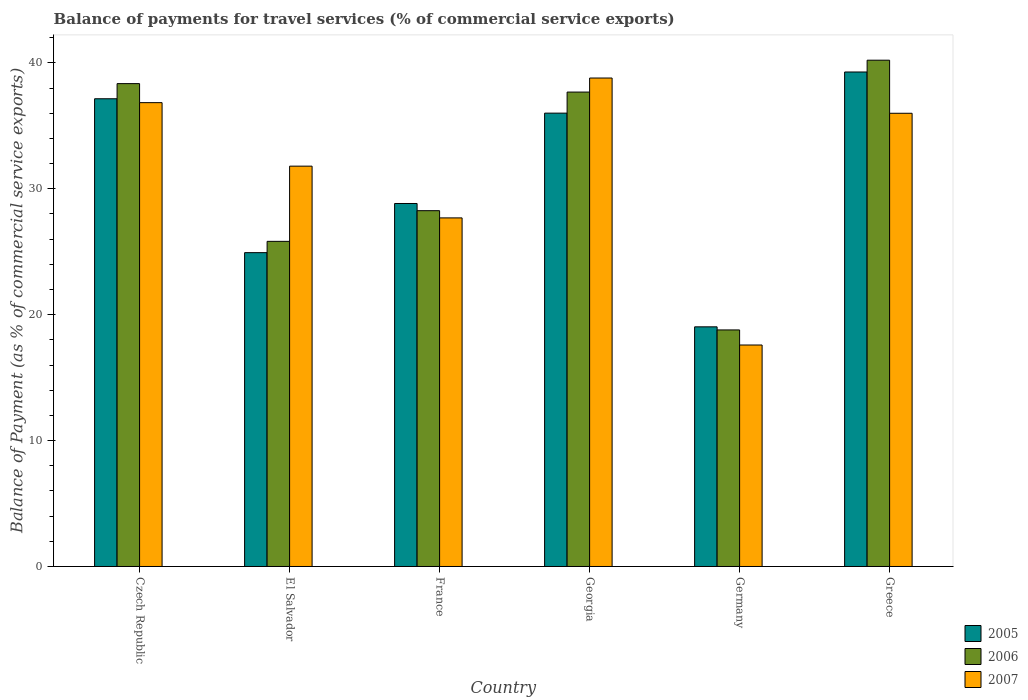How many different coloured bars are there?
Provide a succinct answer. 3. How many groups of bars are there?
Keep it short and to the point. 6. Are the number of bars per tick equal to the number of legend labels?
Keep it short and to the point. Yes. In how many cases, is the number of bars for a given country not equal to the number of legend labels?
Your answer should be compact. 0. What is the balance of payments for travel services in 2007 in El Salvador?
Your answer should be compact. 31.8. Across all countries, what is the maximum balance of payments for travel services in 2006?
Give a very brief answer. 40.22. Across all countries, what is the minimum balance of payments for travel services in 2005?
Make the answer very short. 19.04. In which country was the balance of payments for travel services in 2005 maximum?
Keep it short and to the point. Greece. In which country was the balance of payments for travel services in 2005 minimum?
Give a very brief answer. Germany. What is the total balance of payments for travel services in 2005 in the graph?
Offer a very short reply. 185.24. What is the difference between the balance of payments for travel services in 2005 in Czech Republic and that in Greece?
Ensure brevity in your answer.  -2.13. What is the difference between the balance of payments for travel services in 2006 in Germany and the balance of payments for travel services in 2005 in Georgia?
Ensure brevity in your answer.  -17.22. What is the average balance of payments for travel services in 2006 per country?
Provide a short and direct response. 31.52. What is the difference between the balance of payments for travel services of/in 2005 and balance of payments for travel services of/in 2007 in El Salvador?
Provide a short and direct response. -6.87. In how many countries, is the balance of payments for travel services in 2007 greater than 8 %?
Ensure brevity in your answer.  6. What is the ratio of the balance of payments for travel services in 2006 in Czech Republic to that in Greece?
Give a very brief answer. 0.95. Is the balance of payments for travel services in 2007 in Czech Republic less than that in Germany?
Give a very brief answer. No. What is the difference between the highest and the second highest balance of payments for travel services in 2007?
Keep it short and to the point. -0.84. What is the difference between the highest and the lowest balance of payments for travel services in 2007?
Your answer should be very brief. 21.21. What does the 2nd bar from the left in Czech Republic represents?
Keep it short and to the point. 2006. What does the 1st bar from the right in Greece represents?
Keep it short and to the point. 2007. Is it the case that in every country, the sum of the balance of payments for travel services in 2006 and balance of payments for travel services in 2005 is greater than the balance of payments for travel services in 2007?
Keep it short and to the point. Yes. How many countries are there in the graph?
Provide a succinct answer. 6. What is the difference between two consecutive major ticks on the Y-axis?
Your answer should be compact. 10. Are the values on the major ticks of Y-axis written in scientific E-notation?
Provide a succinct answer. No. Does the graph contain any zero values?
Offer a very short reply. No. Where does the legend appear in the graph?
Provide a short and direct response. Bottom right. How many legend labels are there?
Offer a terse response. 3. What is the title of the graph?
Your response must be concise. Balance of payments for travel services (% of commercial service exports). What is the label or title of the Y-axis?
Provide a succinct answer. Balance of Payment (as % of commercial service exports). What is the Balance of Payment (as % of commercial service exports) in 2005 in Czech Republic?
Your answer should be compact. 37.15. What is the Balance of Payment (as % of commercial service exports) of 2006 in Czech Republic?
Make the answer very short. 38.36. What is the Balance of Payment (as % of commercial service exports) in 2007 in Czech Republic?
Make the answer very short. 36.84. What is the Balance of Payment (as % of commercial service exports) in 2005 in El Salvador?
Your answer should be very brief. 24.93. What is the Balance of Payment (as % of commercial service exports) in 2006 in El Salvador?
Offer a terse response. 25.83. What is the Balance of Payment (as % of commercial service exports) in 2007 in El Salvador?
Your response must be concise. 31.8. What is the Balance of Payment (as % of commercial service exports) of 2005 in France?
Offer a terse response. 28.83. What is the Balance of Payment (as % of commercial service exports) in 2006 in France?
Provide a succinct answer. 28.26. What is the Balance of Payment (as % of commercial service exports) of 2007 in France?
Your response must be concise. 27.69. What is the Balance of Payment (as % of commercial service exports) in 2005 in Georgia?
Offer a terse response. 36.01. What is the Balance of Payment (as % of commercial service exports) of 2006 in Georgia?
Keep it short and to the point. 37.68. What is the Balance of Payment (as % of commercial service exports) in 2007 in Georgia?
Ensure brevity in your answer.  38.8. What is the Balance of Payment (as % of commercial service exports) in 2005 in Germany?
Your answer should be compact. 19.04. What is the Balance of Payment (as % of commercial service exports) in 2006 in Germany?
Your response must be concise. 18.79. What is the Balance of Payment (as % of commercial service exports) in 2007 in Germany?
Keep it short and to the point. 17.59. What is the Balance of Payment (as % of commercial service exports) in 2005 in Greece?
Your answer should be very brief. 39.28. What is the Balance of Payment (as % of commercial service exports) of 2006 in Greece?
Keep it short and to the point. 40.22. What is the Balance of Payment (as % of commercial service exports) in 2007 in Greece?
Your answer should be compact. 36. Across all countries, what is the maximum Balance of Payment (as % of commercial service exports) in 2005?
Provide a short and direct response. 39.28. Across all countries, what is the maximum Balance of Payment (as % of commercial service exports) of 2006?
Give a very brief answer. 40.22. Across all countries, what is the maximum Balance of Payment (as % of commercial service exports) in 2007?
Your answer should be very brief. 38.8. Across all countries, what is the minimum Balance of Payment (as % of commercial service exports) in 2005?
Give a very brief answer. 19.04. Across all countries, what is the minimum Balance of Payment (as % of commercial service exports) in 2006?
Make the answer very short. 18.79. Across all countries, what is the minimum Balance of Payment (as % of commercial service exports) of 2007?
Keep it short and to the point. 17.59. What is the total Balance of Payment (as % of commercial service exports) of 2005 in the graph?
Your answer should be very brief. 185.24. What is the total Balance of Payment (as % of commercial service exports) of 2006 in the graph?
Your answer should be very brief. 189.14. What is the total Balance of Payment (as % of commercial service exports) in 2007 in the graph?
Your response must be concise. 188.73. What is the difference between the Balance of Payment (as % of commercial service exports) of 2005 in Czech Republic and that in El Salvador?
Offer a terse response. 12.22. What is the difference between the Balance of Payment (as % of commercial service exports) of 2006 in Czech Republic and that in El Salvador?
Your response must be concise. 12.53. What is the difference between the Balance of Payment (as % of commercial service exports) of 2007 in Czech Republic and that in El Salvador?
Provide a succinct answer. 5.04. What is the difference between the Balance of Payment (as % of commercial service exports) of 2005 in Czech Republic and that in France?
Your response must be concise. 8.32. What is the difference between the Balance of Payment (as % of commercial service exports) in 2006 in Czech Republic and that in France?
Your response must be concise. 10.09. What is the difference between the Balance of Payment (as % of commercial service exports) of 2007 in Czech Republic and that in France?
Your answer should be very brief. 9.15. What is the difference between the Balance of Payment (as % of commercial service exports) in 2005 in Czech Republic and that in Georgia?
Give a very brief answer. 1.14. What is the difference between the Balance of Payment (as % of commercial service exports) of 2006 in Czech Republic and that in Georgia?
Ensure brevity in your answer.  0.67. What is the difference between the Balance of Payment (as % of commercial service exports) in 2007 in Czech Republic and that in Georgia?
Your response must be concise. -1.96. What is the difference between the Balance of Payment (as % of commercial service exports) in 2005 in Czech Republic and that in Germany?
Offer a very short reply. 18.12. What is the difference between the Balance of Payment (as % of commercial service exports) in 2006 in Czech Republic and that in Germany?
Provide a succinct answer. 19.57. What is the difference between the Balance of Payment (as % of commercial service exports) of 2007 in Czech Republic and that in Germany?
Offer a terse response. 19.25. What is the difference between the Balance of Payment (as % of commercial service exports) in 2005 in Czech Republic and that in Greece?
Make the answer very short. -2.13. What is the difference between the Balance of Payment (as % of commercial service exports) in 2006 in Czech Republic and that in Greece?
Provide a short and direct response. -1.86. What is the difference between the Balance of Payment (as % of commercial service exports) of 2007 in Czech Republic and that in Greece?
Ensure brevity in your answer.  0.84. What is the difference between the Balance of Payment (as % of commercial service exports) in 2005 in El Salvador and that in France?
Provide a short and direct response. -3.91. What is the difference between the Balance of Payment (as % of commercial service exports) in 2006 in El Salvador and that in France?
Your answer should be very brief. -2.44. What is the difference between the Balance of Payment (as % of commercial service exports) of 2007 in El Salvador and that in France?
Your answer should be compact. 4.11. What is the difference between the Balance of Payment (as % of commercial service exports) in 2005 in El Salvador and that in Georgia?
Provide a succinct answer. -11.08. What is the difference between the Balance of Payment (as % of commercial service exports) in 2006 in El Salvador and that in Georgia?
Offer a very short reply. -11.86. What is the difference between the Balance of Payment (as % of commercial service exports) in 2007 in El Salvador and that in Georgia?
Offer a very short reply. -7. What is the difference between the Balance of Payment (as % of commercial service exports) in 2005 in El Salvador and that in Germany?
Your answer should be very brief. 5.89. What is the difference between the Balance of Payment (as % of commercial service exports) in 2006 in El Salvador and that in Germany?
Make the answer very short. 7.04. What is the difference between the Balance of Payment (as % of commercial service exports) in 2007 in El Salvador and that in Germany?
Keep it short and to the point. 14.21. What is the difference between the Balance of Payment (as % of commercial service exports) of 2005 in El Salvador and that in Greece?
Offer a terse response. -14.35. What is the difference between the Balance of Payment (as % of commercial service exports) in 2006 in El Salvador and that in Greece?
Your answer should be compact. -14.39. What is the difference between the Balance of Payment (as % of commercial service exports) of 2007 in El Salvador and that in Greece?
Offer a very short reply. -4.2. What is the difference between the Balance of Payment (as % of commercial service exports) of 2005 in France and that in Georgia?
Offer a terse response. -7.18. What is the difference between the Balance of Payment (as % of commercial service exports) in 2006 in France and that in Georgia?
Your answer should be compact. -9.42. What is the difference between the Balance of Payment (as % of commercial service exports) of 2007 in France and that in Georgia?
Offer a very short reply. -11.11. What is the difference between the Balance of Payment (as % of commercial service exports) of 2005 in France and that in Germany?
Offer a very short reply. 9.8. What is the difference between the Balance of Payment (as % of commercial service exports) of 2006 in France and that in Germany?
Your response must be concise. 9.47. What is the difference between the Balance of Payment (as % of commercial service exports) in 2007 in France and that in Germany?
Give a very brief answer. 10.1. What is the difference between the Balance of Payment (as % of commercial service exports) of 2005 in France and that in Greece?
Keep it short and to the point. -10.45. What is the difference between the Balance of Payment (as % of commercial service exports) of 2006 in France and that in Greece?
Ensure brevity in your answer.  -11.95. What is the difference between the Balance of Payment (as % of commercial service exports) of 2007 in France and that in Greece?
Offer a terse response. -8.31. What is the difference between the Balance of Payment (as % of commercial service exports) of 2005 in Georgia and that in Germany?
Provide a succinct answer. 16.97. What is the difference between the Balance of Payment (as % of commercial service exports) in 2006 in Georgia and that in Germany?
Your answer should be very brief. 18.89. What is the difference between the Balance of Payment (as % of commercial service exports) in 2007 in Georgia and that in Germany?
Your answer should be very brief. 21.21. What is the difference between the Balance of Payment (as % of commercial service exports) of 2005 in Georgia and that in Greece?
Keep it short and to the point. -3.27. What is the difference between the Balance of Payment (as % of commercial service exports) of 2006 in Georgia and that in Greece?
Keep it short and to the point. -2.53. What is the difference between the Balance of Payment (as % of commercial service exports) of 2005 in Germany and that in Greece?
Keep it short and to the point. -20.24. What is the difference between the Balance of Payment (as % of commercial service exports) of 2006 in Germany and that in Greece?
Provide a short and direct response. -21.43. What is the difference between the Balance of Payment (as % of commercial service exports) of 2007 in Germany and that in Greece?
Your answer should be very brief. -18.41. What is the difference between the Balance of Payment (as % of commercial service exports) of 2005 in Czech Republic and the Balance of Payment (as % of commercial service exports) of 2006 in El Salvador?
Your answer should be compact. 11.33. What is the difference between the Balance of Payment (as % of commercial service exports) in 2005 in Czech Republic and the Balance of Payment (as % of commercial service exports) in 2007 in El Salvador?
Your answer should be compact. 5.35. What is the difference between the Balance of Payment (as % of commercial service exports) in 2006 in Czech Republic and the Balance of Payment (as % of commercial service exports) in 2007 in El Salvador?
Your answer should be very brief. 6.56. What is the difference between the Balance of Payment (as % of commercial service exports) in 2005 in Czech Republic and the Balance of Payment (as % of commercial service exports) in 2006 in France?
Offer a terse response. 8.89. What is the difference between the Balance of Payment (as % of commercial service exports) of 2005 in Czech Republic and the Balance of Payment (as % of commercial service exports) of 2007 in France?
Provide a short and direct response. 9.46. What is the difference between the Balance of Payment (as % of commercial service exports) of 2006 in Czech Republic and the Balance of Payment (as % of commercial service exports) of 2007 in France?
Your answer should be very brief. 10.67. What is the difference between the Balance of Payment (as % of commercial service exports) of 2005 in Czech Republic and the Balance of Payment (as % of commercial service exports) of 2006 in Georgia?
Your answer should be compact. -0.53. What is the difference between the Balance of Payment (as % of commercial service exports) in 2005 in Czech Republic and the Balance of Payment (as % of commercial service exports) in 2007 in Georgia?
Provide a short and direct response. -1.65. What is the difference between the Balance of Payment (as % of commercial service exports) in 2006 in Czech Republic and the Balance of Payment (as % of commercial service exports) in 2007 in Georgia?
Make the answer very short. -0.44. What is the difference between the Balance of Payment (as % of commercial service exports) in 2005 in Czech Republic and the Balance of Payment (as % of commercial service exports) in 2006 in Germany?
Ensure brevity in your answer.  18.36. What is the difference between the Balance of Payment (as % of commercial service exports) of 2005 in Czech Republic and the Balance of Payment (as % of commercial service exports) of 2007 in Germany?
Your answer should be very brief. 19.56. What is the difference between the Balance of Payment (as % of commercial service exports) of 2006 in Czech Republic and the Balance of Payment (as % of commercial service exports) of 2007 in Germany?
Make the answer very short. 20.76. What is the difference between the Balance of Payment (as % of commercial service exports) in 2005 in Czech Republic and the Balance of Payment (as % of commercial service exports) in 2006 in Greece?
Provide a succinct answer. -3.06. What is the difference between the Balance of Payment (as % of commercial service exports) in 2005 in Czech Republic and the Balance of Payment (as % of commercial service exports) in 2007 in Greece?
Your response must be concise. 1.15. What is the difference between the Balance of Payment (as % of commercial service exports) of 2006 in Czech Republic and the Balance of Payment (as % of commercial service exports) of 2007 in Greece?
Offer a very short reply. 2.36. What is the difference between the Balance of Payment (as % of commercial service exports) in 2005 in El Salvador and the Balance of Payment (as % of commercial service exports) in 2006 in France?
Provide a short and direct response. -3.33. What is the difference between the Balance of Payment (as % of commercial service exports) of 2005 in El Salvador and the Balance of Payment (as % of commercial service exports) of 2007 in France?
Provide a short and direct response. -2.76. What is the difference between the Balance of Payment (as % of commercial service exports) of 2006 in El Salvador and the Balance of Payment (as % of commercial service exports) of 2007 in France?
Your response must be concise. -1.86. What is the difference between the Balance of Payment (as % of commercial service exports) of 2005 in El Salvador and the Balance of Payment (as % of commercial service exports) of 2006 in Georgia?
Keep it short and to the point. -12.76. What is the difference between the Balance of Payment (as % of commercial service exports) in 2005 in El Salvador and the Balance of Payment (as % of commercial service exports) in 2007 in Georgia?
Ensure brevity in your answer.  -13.87. What is the difference between the Balance of Payment (as % of commercial service exports) of 2006 in El Salvador and the Balance of Payment (as % of commercial service exports) of 2007 in Georgia?
Ensure brevity in your answer.  -12.97. What is the difference between the Balance of Payment (as % of commercial service exports) in 2005 in El Salvador and the Balance of Payment (as % of commercial service exports) in 2006 in Germany?
Your answer should be compact. 6.14. What is the difference between the Balance of Payment (as % of commercial service exports) in 2005 in El Salvador and the Balance of Payment (as % of commercial service exports) in 2007 in Germany?
Give a very brief answer. 7.34. What is the difference between the Balance of Payment (as % of commercial service exports) in 2006 in El Salvador and the Balance of Payment (as % of commercial service exports) in 2007 in Germany?
Offer a terse response. 8.23. What is the difference between the Balance of Payment (as % of commercial service exports) in 2005 in El Salvador and the Balance of Payment (as % of commercial service exports) in 2006 in Greece?
Provide a short and direct response. -15.29. What is the difference between the Balance of Payment (as % of commercial service exports) in 2005 in El Salvador and the Balance of Payment (as % of commercial service exports) in 2007 in Greece?
Your answer should be compact. -11.07. What is the difference between the Balance of Payment (as % of commercial service exports) of 2006 in El Salvador and the Balance of Payment (as % of commercial service exports) of 2007 in Greece?
Ensure brevity in your answer.  -10.17. What is the difference between the Balance of Payment (as % of commercial service exports) in 2005 in France and the Balance of Payment (as % of commercial service exports) in 2006 in Georgia?
Ensure brevity in your answer.  -8.85. What is the difference between the Balance of Payment (as % of commercial service exports) in 2005 in France and the Balance of Payment (as % of commercial service exports) in 2007 in Georgia?
Your response must be concise. -9.97. What is the difference between the Balance of Payment (as % of commercial service exports) of 2006 in France and the Balance of Payment (as % of commercial service exports) of 2007 in Georgia?
Give a very brief answer. -10.54. What is the difference between the Balance of Payment (as % of commercial service exports) in 2005 in France and the Balance of Payment (as % of commercial service exports) in 2006 in Germany?
Your response must be concise. 10.04. What is the difference between the Balance of Payment (as % of commercial service exports) of 2005 in France and the Balance of Payment (as % of commercial service exports) of 2007 in Germany?
Ensure brevity in your answer.  11.24. What is the difference between the Balance of Payment (as % of commercial service exports) of 2006 in France and the Balance of Payment (as % of commercial service exports) of 2007 in Germany?
Offer a very short reply. 10.67. What is the difference between the Balance of Payment (as % of commercial service exports) in 2005 in France and the Balance of Payment (as % of commercial service exports) in 2006 in Greece?
Ensure brevity in your answer.  -11.38. What is the difference between the Balance of Payment (as % of commercial service exports) in 2005 in France and the Balance of Payment (as % of commercial service exports) in 2007 in Greece?
Make the answer very short. -7.17. What is the difference between the Balance of Payment (as % of commercial service exports) of 2006 in France and the Balance of Payment (as % of commercial service exports) of 2007 in Greece?
Your answer should be very brief. -7.74. What is the difference between the Balance of Payment (as % of commercial service exports) of 2005 in Georgia and the Balance of Payment (as % of commercial service exports) of 2006 in Germany?
Your answer should be compact. 17.22. What is the difference between the Balance of Payment (as % of commercial service exports) in 2005 in Georgia and the Balance of Payment (as % of commercial service exports) in 2007 in Germany?
Ensure brevity in your answer.  18.42. What is the difference between the Balance of Payment (as % of commercial service exports) of 2006 in Georgia and the Balance of Payment (as % of commercial service exports) of 2007 in Germany?
Provide a short and direct response. 20.09. What is the difference between the Balance of Payment (as % of commercial service exports) in 2005 in Georgia and the Balance of Payment (as % of commercial service exports) in 2006 in Greece?
Provide a succinct answer. -4.21. What is the difference between the Balance of Payment (as % of commercial service exports) in 2005 in Georgia and the Balance of Payment (as % of commercial service exports) in 2007 in Greece?
Keep it short and to the point. 0.01. What is the difference between the Balance of Payment (as % of commercial service exports) of 2006 in Georgia and the Balance of Payment (as % of commercial service exports) of 2007 in Greece?
Your answer should be compact. 1.69. What is the difference between the Balance of Payment (as % of commercial service exports) in 2005 in Germany and the Balance of Payment (as % of commercial service exports) in 2006 in Greece?
Offer a terse response. -21.18. What is the difference between the Balance of Payment (as % of commercial service exports) of 2005 in Germany and the Balance of Payment (as % of commercial service exports) of 2007 in Greece?
Give a very brief answer. -16.96. What is the difference between the Balance of Payment (as % of commercial service exports) of 2006 in Germany and the Balance of Payment (as % of commercial service exports) of 2007 in Greece?
Your answer should be compact. -17.21. What is the average Balance of Payment (as % of commercial service exports) of 2005 per country?
Give a very brief answer. 30.87. What is the average Balance of Payment (as % of commercial service exports) of 2006 per country?
Give a very brief answer. 31.52. What is the average Balance of Payment (as % of commercial service exports) in 2007 per country?
Ensure brevity in your answer.  31.45. What is the difference between the Balance of Payment (as % of commercial service exports) of 2005 and Balance of Payment (as % of commercial service exports) of 2006 in Czech Republic?
Offer a terse response. -1.2. What is the difference between the Balance of Payment (as % of commercial service exports) in 2005 and Balance of Payment (as % of commercial service exports) in 2007 in Czech Republic?
Provide a succinct answer. 0.31. What is the difference between the Balance of Payment (as % of commercial service exports) of 2006 and Balance of Payment (as % of commercial service exports) of 2007 in Czech Republic?
Offer a very short reply. 1.51. What is the difference between the Balance of Payment (as % of commercial service exports) of 2005 and Balance of Payment (as % of commercial service exports) of 2006 in El Salvador?
Your answer should be compact. -0.9. What is the difference between the Balance of Payment (as % of commercial service exports) of 2005 and Balance of Payment (as % of commercial service exports) of 2007 in El Salvador?
Provide a succinct answer. -6.87. What is the difference between the Balance of Payment (as % of commercial service exports) in 2006 and Balance of Payment (as % of commercial service exports) in 2007 in El Salvador?
Offer a terse response. -5.97. What is the difference between the Balance of Payment (as % of commercial service exports) in 2005 and Balance of Payment (as % of commercial service exports) in 2006 in France?
Make the answer very short. 0.57. What is the difference between the Balance of Payment (as % of commercial service exports) in 2005 and Balance of Payment (as % of commercial service exports) in 2007 in France?
Offer a very short reply. 1.14. What is the difference between the Balance of Payment (as % of commercial service exports) in 2006 and Balance of Payment (as % of commercial service exports) in 2007 in France?
Keep it short and to the point. 0.57. What is the difference between the Balance of Payment (as % of commercial service exports) of 2005 and Balance of Payment (as % of commercial service exports) of 2006 in Georgia?
Provide a short and direct response. -1.67. What is the difference between the Balance of Payment (as % of commercial service exports) in 2005 and Balance of Payment (as % of commercial service exports) in 2007 in Georgia?
Your response must be concise. -2.79. What is the difference between the Balance of Payment (as % of commercial service exports) in 2006 and Balance of Payment (as % of commercial service exports) in 2007 in Georgia?
Provide a short and direct response. -1.11. What is the difference between the Balance of Payment (as % of commercial service exports) of 2005 and Balance of Payment (as % of commercial service exports) of 2006 in Germany?
Offer a very short reply. 0.25. What is the difference between the Balance of Payment (as % of commercial service exports) of 2005 and Balance of Payment (as % of commercial service exports) of 2007 in Germany?
Your response must be concise. 1.44. What is the difference between the Balance of Payment (as % of commercial service exports) of 2006 and Balance of Payment (as % of commercial service exports) of 2007 in Germany?
Give a very brief answer. 1.2. What is the difference between the Balance of Payment (as % of commercial service exports) in 2005 and Balance of Payment (as % of commercial service exports) in 2006 in Greece?
Offer a very short reply. -0.94. What is the difference between the Balance of Payment (as % of commercial service exports) of 2005 and Balance of Payment (as % of commercial service exports) of 2007 in Greece?
Make the answer very short. 3.28. What is the difference between the Balance of Payment (as % of commercial service exports) of 2006 and Balance of Payment (as % of commercial service exports) of 2007 in Greece?
Offer a terse response. 4.22. What is the ratio of the Balance of Payment (as % of commercial service exports) of 2005 in Czech Republic to that in El Salvador?
Provide a succinct answer. 1.49. What is the ratio of the Balance of Payment (as % of commercial service exports) in 2006 in Czech Republic to that in El Salvador?
Provide a succinct answer. 1.49. What is the ratio of the Balance of Payment (as % of commercial service exports) of 2007 in Czech Republic to that in El Salvador?
Your answer should be compact. 1.16. What is the ratio of the Balance of Payment (as % of commercial service exports) of 2005 in Czech Republic to that in France?
Keep it short and to the point. 1.29. What is the ratio of the Balance of Payment (as % of commercial service exports) of 2006 in Czech Republic to that in France?
Offer a very short reply. 1.36. What is the ratio of the Balance of Payment (as % of commercial service exports) in 2007 in Czech Republic to that in France?
Provide a short and direct response. 1.33. What is the ratio of the Balance of Payment (as % of commercial service exports) in 2005 in Czech Republic to that in Georgia?
Offer a very short reply. 1.03. What is the ratio of the Balance of Payment (as % of commercial service exports) in 2006 in Czech Republic to that in Georgia?
Provide a succinct answer. 1.02. What is the ratio of the Balance of Payment (as % of commercial service exports) in 2007 in Czech Republic to that in Georgia?
Give a very brief answer. 0.95. What is the ratio of the Balance of Payment (as % of commercial service exports) in 2005 in Czech Republic to that in Germany?
Offer a very short reply. 1.95. What is the ratio of the Balance of Payment (as % of commercial service exports) in 2006 in Czech Republic to that in Germany?
Your answer should be compact. 2.04. What is the ratio of the Balance of Payment (as % of commercial service exports) of 2007 in Czech Republic to that in Germany?
Your answer should be very brief. 2.09. What is the ratio of the Balance of Payment (as % of commercial service exports) of 2005 in Czech Republic to that in Greece?
Keep it short and to the point. 0.95. What is the ratio of the Balance of Payment (as % of commercial service exports) of 2006 in Czech Republic to that in Greece?
Keep it short and to the point. 0.95. What is the ratio of the Balance of Payment (as % of commercial service exports) of 2007 in Czech Republic to that in Greece?
Offer a very short reply. 1.02. What is the ratio of the Balance of Payment (as % of commercial service exports) in 2005 in El Salvador to that in France?
Give a very brief answer. 0.86. What is the ratio of the Balance of Payment (as % of commercial service exports) in 2006 in El Salvador to that in France?
Keep it short and to the point. 0.91. What is the ratio of the Balance of Payment (as % of commercial service exports) of 2007 in El Salvador to that in France?
Offer a terse response. 1.15. What is the ratio of the Balance of Payment (as % of commercial service exports) of 2005 in El Salvador to that in Georgia?
Provide a short and direct response. 0.69. What is the ratio of the Balance of Payment (as % of commercial service exports) of 2006 in El Salvador to that in Georgia?
Provide a short and direct response. 0.69. What is the ratio of the Balance of Payment (as % of commercial service exports) of 2007 in El Salvador to that in Georgia?
Ensure brevity in your answer.  0.82. What is the ratio of the Balance of Payment (as % of commercial service exports) in 2005 in El Salvador to that in Germany?
Give a very brief answer. 1.31. What is the ratio of the Balance of Payment (as % of commercial service exports) in 2006 in El Salvador to that in Germany?
Provide a short and direct response. 1.37. What is the ratio of the Balance of Payment (as % of commercial service exports) in 2007 in El Salvador to that in Germany?
Your answer should be very brief. 1.81. What is the ratio of the Balance of Payment (as % of commercial service exports) of 2005 in El Salvador to that in Greece?
Give a very brief answer. 0.63. What is the ratio of the Balance of Payment (as % of commercial service exports) in 2006 in El Salvador to that in Greece?
Your answer should be compact. 0.64. What is the ratio of the Balance of Payment (as % of commercial service exports) in 2007 in El Salvador to that in Greece?
Give a very brief answer. 0.88. What is the ratio of the Balance of Payment (as % of commercial service exports) in 2005 in France to that in Georgia?
Give a very brief answer. 0.8. What is the ratio of the Balance of Payment (as % of commercial service exports) of 2006 in France to that in Georgia?
Provide a short and direct response. 0.75. What is the ratio of the Balance of Payment (as % of commercial service exports) of 2007 in France to that in Georgia?
Provide a short and direct response. 0.71. What is the ratio of the Balance of Payment (as % of commercial service exports) in 2005 in France to that in Germany?
Your response must be concise. 1.51. What is the ratio of the Balance of Payment (as % of commercial service exports) in 2006 in France to that in Germany?
Ensure brevity in your answer.  1.5. What is the ratio of the Balance of Payment (as % of commercial service exports) of 2007 in France to that in Germany?
Offer a terse response. 1.57. What is the ratio of the Balance of Payment (as % of commercial service exports) of 2005 in France to that in Greece?
Make the answer very short. 0.73. What is the ratio of the Balance of Payment (as % of commercial service exports) of 2006 in France to that in Greece?
Your answer should be compact. 0.7. What is the ratio of the Balance of Payment (as % of commercial service exports) of 2007 in France to that in Greece?
Your answer should be compact. 0.77. What is the ratio of the Balance of Payment (as % of commercial service exports) of 2005 in Georgia to that in Germany?
Your answer should be compact. 1.89. What is the ratio of the Balance of Payment (as % of commercial service exports) in 2006 in Georgia to that in Germany?
Your answer should be compact. 2.01. What is the ratio of the Balance of Payment (as % of commercial service exports) in 2007 in Georgia to that in Germany?
Ensure brevity in your answer.  2.21. What is the ratio of the Balance of Payment (as % of commercial service exports) of 2005 in Georgia to that in Greece?
Give a very brief answer. 0.92. What is the ratio of the Balance of Payment (as % of commercial service exports) of 2006 in Georgia to that in Greece?
Give a very brief answer. 0.94. What is the ratio of the Balance of Payment (as % of commercial service exports) of 2007 in Georgia to that in Greece?
Your answer should be compact. 1.08. What is the ratio of the Balance of Payment (as % of commercial service exports) of 2005 in Germany to that in Greece?
Make the answer very short. 0.48. What is the ratio of the Balance of Payment (as % of commercial service exports) in 2006 in Germany to that in Greece?
Provide a succinct answer. 0.47. What is the ratio of the Balance of Payment (as % of commercial service exports) of 2007 in Germany to that in Greece?
Your answer should be very brief. 0.49. What is the difference between the highest and the second highest Balance of Payment (as % of commercial service exports) in 2005?
Give a very brief answer. 2.13. What is the difference between the highest and the second highest Balance of Payment (as % of commercial service exports) of 2006?
Provide a short and direct response. 1.86. What is the difference between the highest and the second highest Balance of Payment (as % of commercial service exports) in 2007?
Give a very brief answer. 1.96. What is the difference between the highest and the lowest Balance of Payment (as % of commercial service exports) in 2005?
Your answer should be compact. 20.24. What is the difference between the highest and the lowest Balance of Payment (as % of commercial service exports) in 2006?
Your answer should be very brief. 21.43. What is the difference between the highest and the lowest Balance of Payment (as % of commercial service exports) in 2007?
Provide a short and direct response. 21.21. 